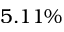Convert formula to latex. <formula><loc_0><loc_0><loc_500><loc_500>5 . 1 1 \%</formula> 